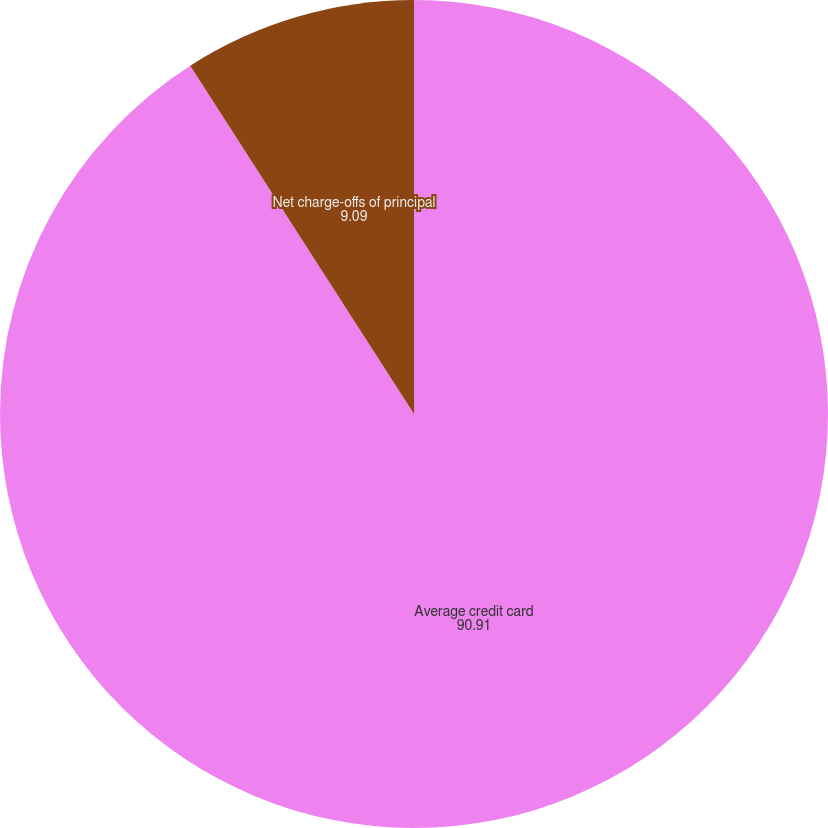Convert chart. <chart><loc_0><loc_0><loc_500><loc_500><pie_chart><fcel>Average credit card<fcel>Net charge-offs of principal<fcel>Net charge-offs as a<nl><fcel>90.91%<fcel>9.09%<fcel>0.0%<nl></chart> 